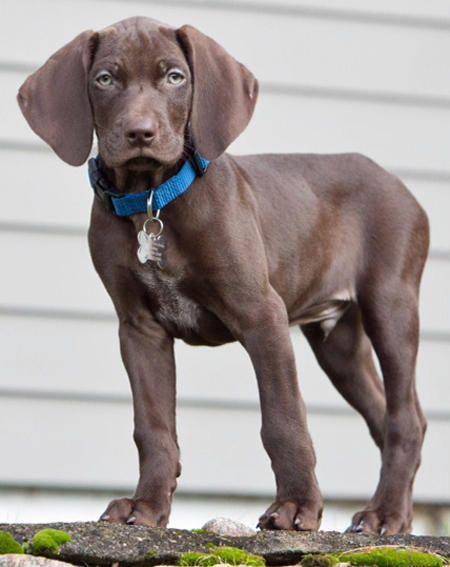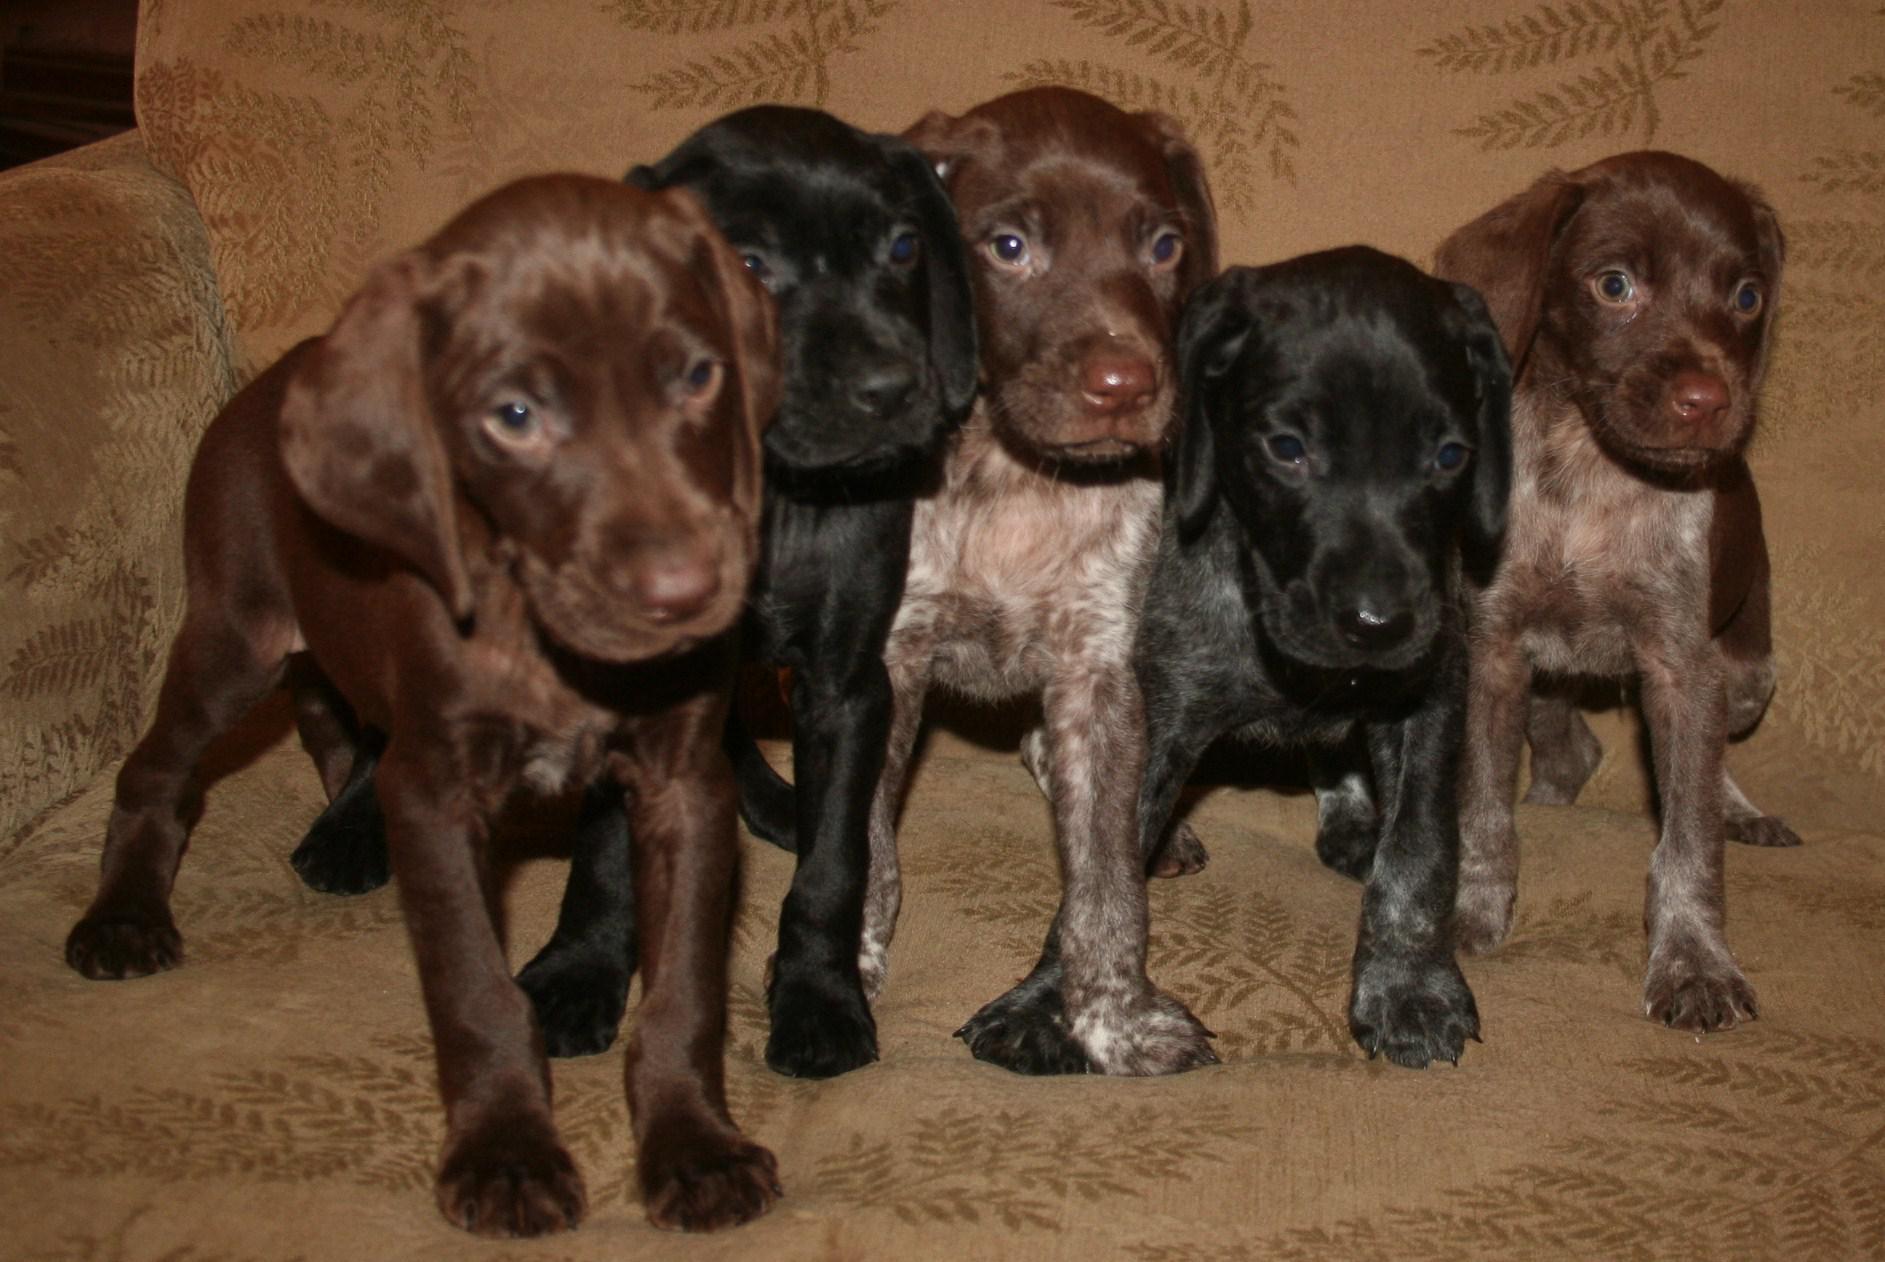The first image is the image on the left, the second image is the image on the right. Assess this claim about the two images: "One image shows a single puppy while the other shows a litter of at least five.". Correct or not? Answer yes or no. Yes. The first image is the image on the left, the second image is the image on the right. For the images displayed, is the sentence "There is one dog in the left image and multiple dogs in the right image." factually correct? Answer yes or no. Yes. 